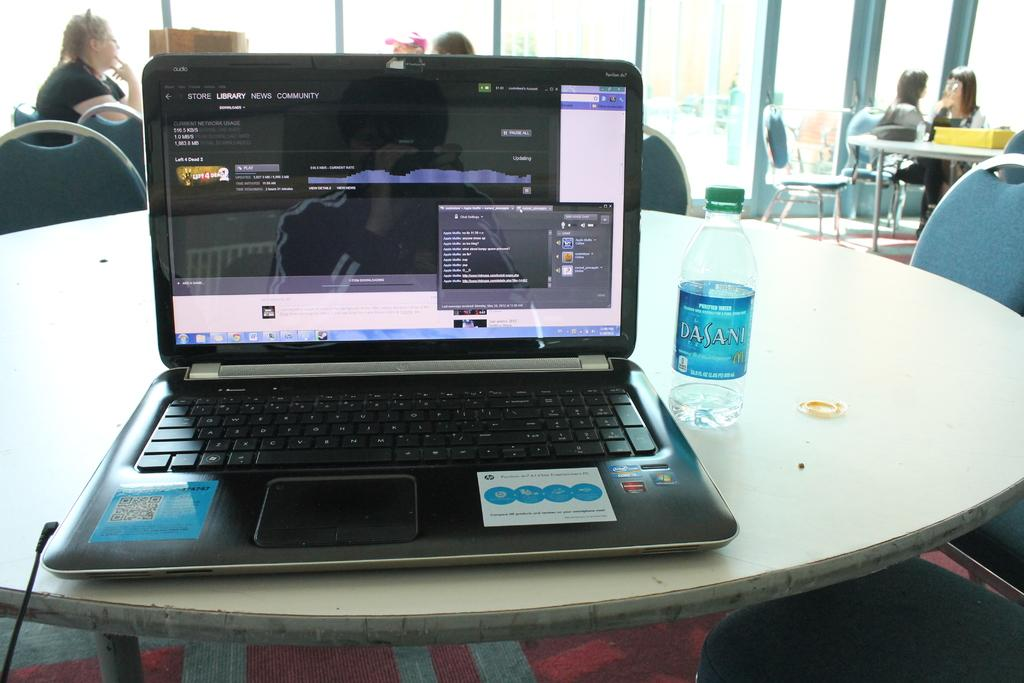<image>
Offer a succinct explanation of the picture presented. A man with a windows laptop is looking up games with a Dasani water bottle near. 